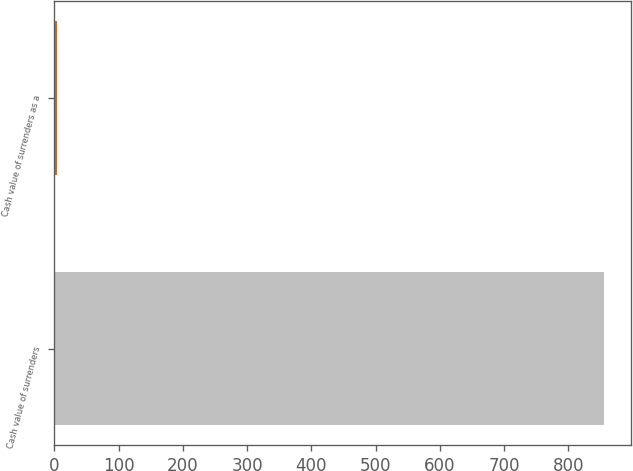Convert chart. <chart><loc_0><loc_0><loc_500><loc_500><bar_chart><fcel>Cash value of surrenders<fcel>Cash value of surrenders as a<nl><fcel>855<fcel>4.2<nl></chart> 